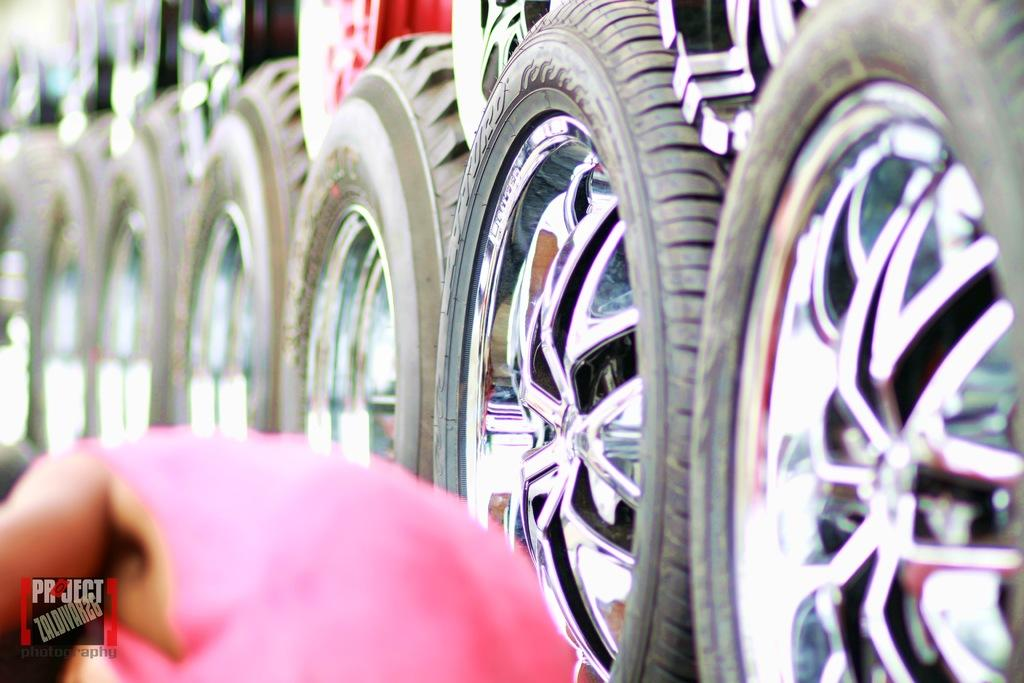Who or what is present at the bottom of the image? There is a person in the image, and they are at the bottom. What can be seen on the right side of the image? There are many tires on the right side of the image. What type of bath can be seen in the image? There is no bath present in the image. What is the person using to hang their clothes on the left side of the image? The image does not show the person hanging clothes or using any hooks. 